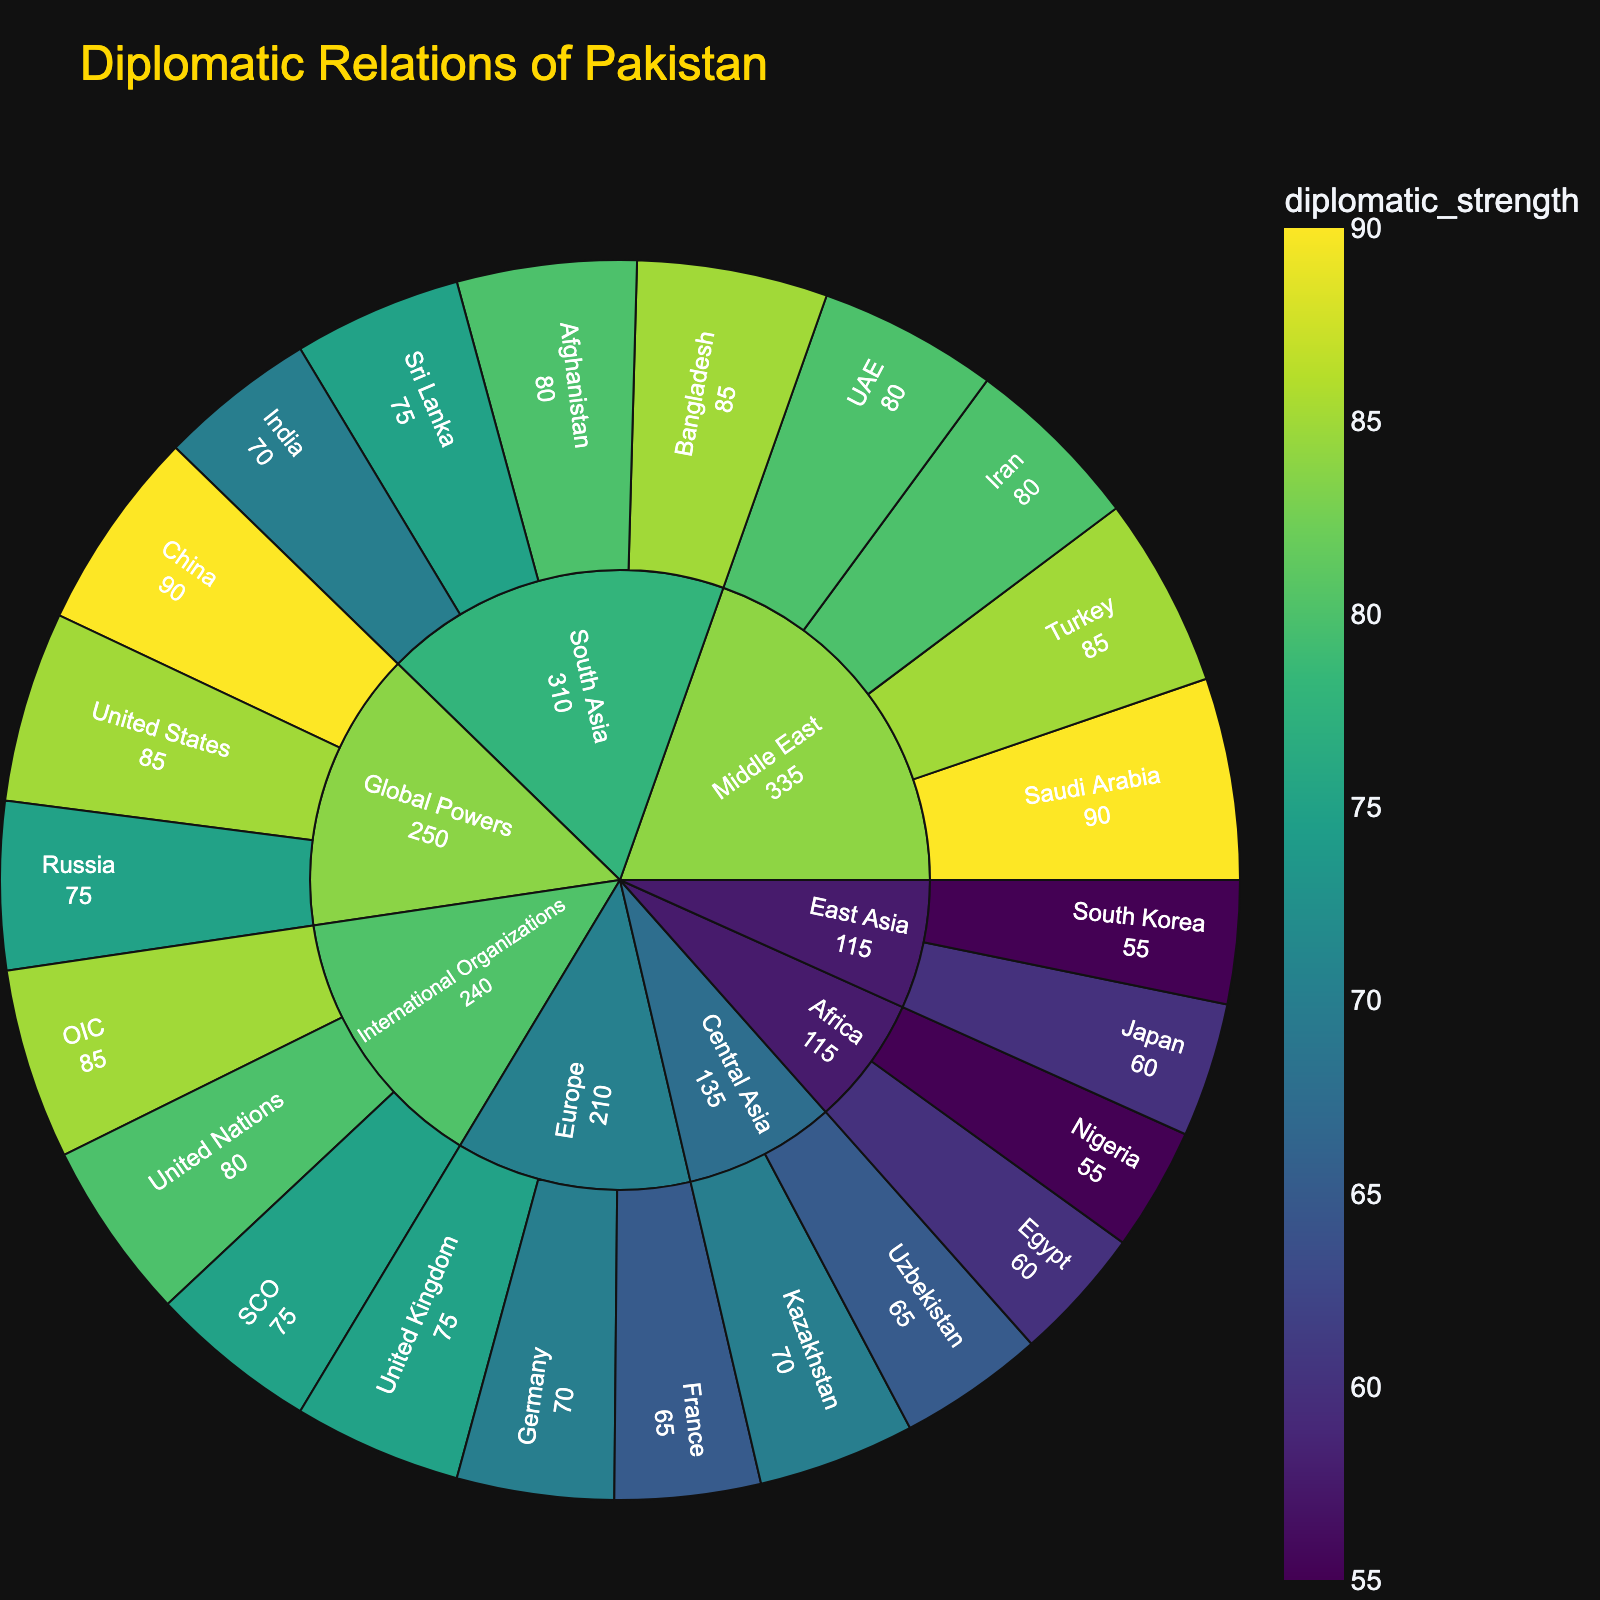What's the title of the plot? The title is displayed at the top of the plot, usually in larger fonts and a different color to differentiate it from the rest of the text.
Answer: Diplomatic Relations of Pakistan Which region has the strongest diplomatic relationship with Pakistan? Check the sunburst plot for the region with the highest aggregate diplomatic strength values and highest color saturation on the color scale.
Answer: Middle East What is the diplomatic strength of Pakistan’s relationship with China? Locate China in the Global Powers section and read the diplomatic strength directly from the plot.
Answer: 90 Which country in South Asia has the weakest diplomatic strength with Pakistan? Identify the South Asia section, look for the country with the smallest value of diplomatic strength within this section.
Answer: India How does Pakistan's diplomatic strength with the United States compare to its strength with Russia? Compare the values of the United States and Russia in the Global Powers section.
Answer: The United States (85) has a higher diplomatic strength compared to Russia (75) Between International Organizations and Europe, which category shows a stronger diplomatic relationship with Pakistan? Sum the diplomatic strengths for all countries in International Organizations and Europe categories, then compare the totals.
Answer: International Organizations What is the total diplomatic strength of Pakistan with the countries listed under the Middle East region? Add the diplomatic strengths of Saudi Arabia (90), Iran (80), Turkey (85), and UAE (80). Total = 90 + 80 + 85 + 80 = 335.
Answer: 335 Which two countries in Central Asia are mentioned, and what are their respective diplomatic strengths? Find the Central Asia section in the plot and note down the names of the countries and their respective strengths.
Answer: Kazakhstan (70) and Uzbekistan (65) How does Pakistan’s diplomatic strength with Germany compare to its strength with Japan? Identify the diplomatic strengths of Germany in the Europe section and Japan in the East Asia section and compare them.
Answer: Germany (70) has a higher diplomatic strength compared to Japan (60) What is the average diplomatic strength of countries in East Asia? Locate the East Asia section, sum the diplomatic strengths of Japan (60) and South Korea (55), and divide by the number of countries. Average = (60 + 55) / 2 = 57.5.
Answer: 57.5 